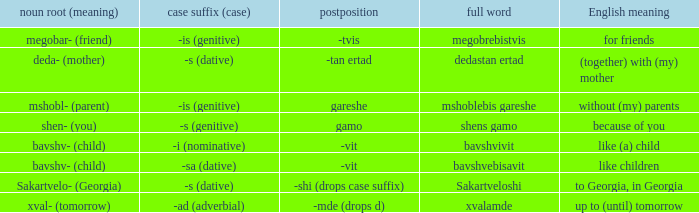What is English Meaning, when Case Suffix (Case) is "-sa (dative)"? Like children. 